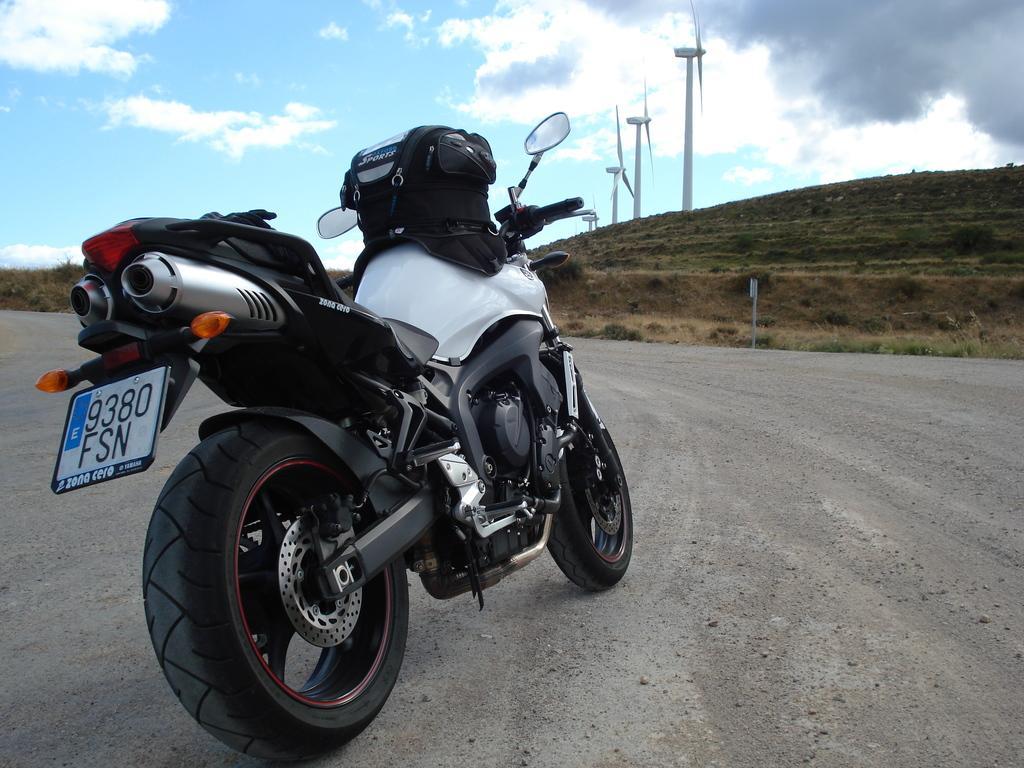Please provide a concise description of this image. In this picture we can see a motorbike on the road and in the background we can see plants, windmills and the sky with clouds. 